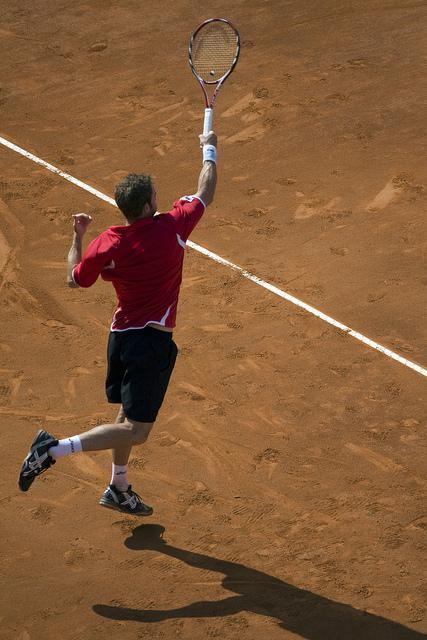How many skis does this person have?
Give a very brief answer. 0. 